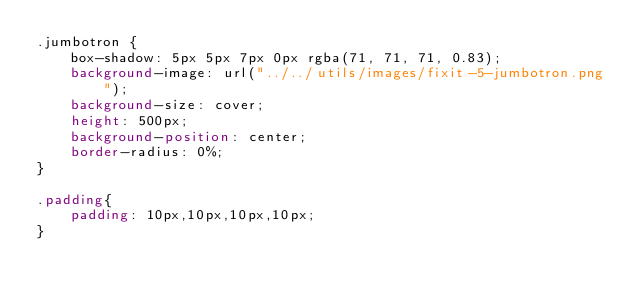<code> <loc_0><loc_0><loc_500><loc_500><_CSS_>.jumbotron {
    box-shadow: 5px 5px 7px 0px rgba(71, 71, 71, 0.83);
    background-image: url("../../utils/images/fixit-5-jumbotron.png");
    background-size: cover;
    height: 500px;
    background-position: center;
    border-radius: 0%;
}

.padding{
    padding: 10px,10px,10px,10px;
}
</code> 